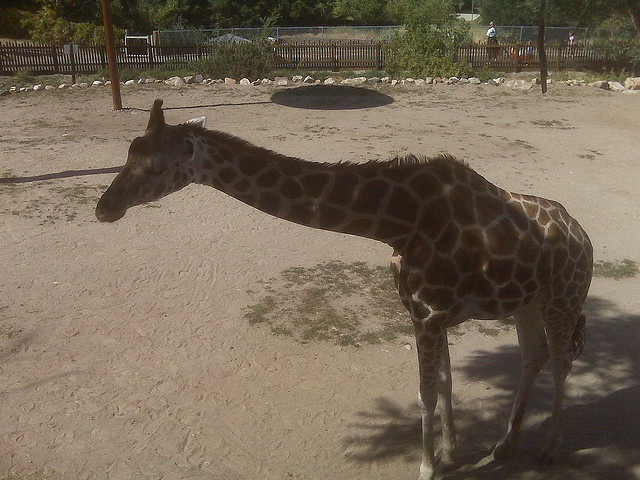Describe the objects in this image and their specific colors. I can see giraffe in black and gray tones, people in black and gray tones, people in black, maroon, and gray tones, and people in black and gray tones in this image. 